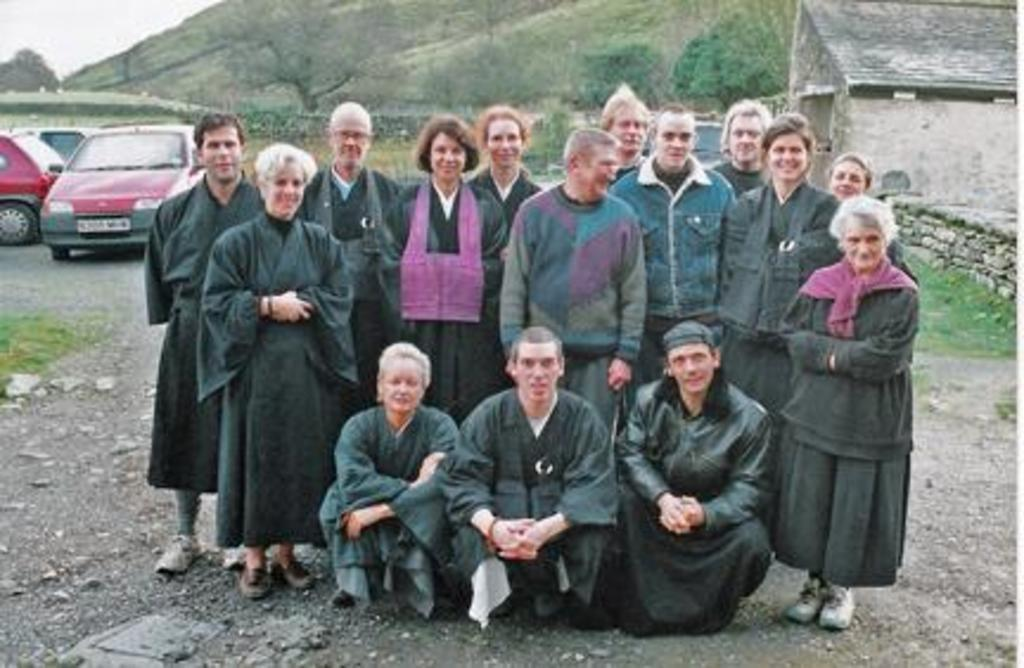What are the people in the image doing? The people in the image are standing and smiling. What can be seen in the background of the image? There is a hill in the background of the image. What type of vegetation is present in the image? Trees are present in the image. What type of structures can be seen in the image? Houses are visible in the image. What else is present in the image besides people and structures? Vehicles are present in the image. What type of soap is being used by the people in the image? There is no soap present in the image; the people are simply standing and smiling. 